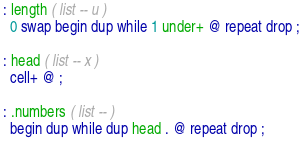<code> <loc_0><loc_0><loc_500><loc_500><_Forth_>: length ( list -- u )
  0 swap begin dup while 1 under+ @ repeat drop ;

: head ( list -- x )
  cell+ @ ;

: .numbers ( list -- )
  begin dup while dup head . @ repeat drop ;
</code> 